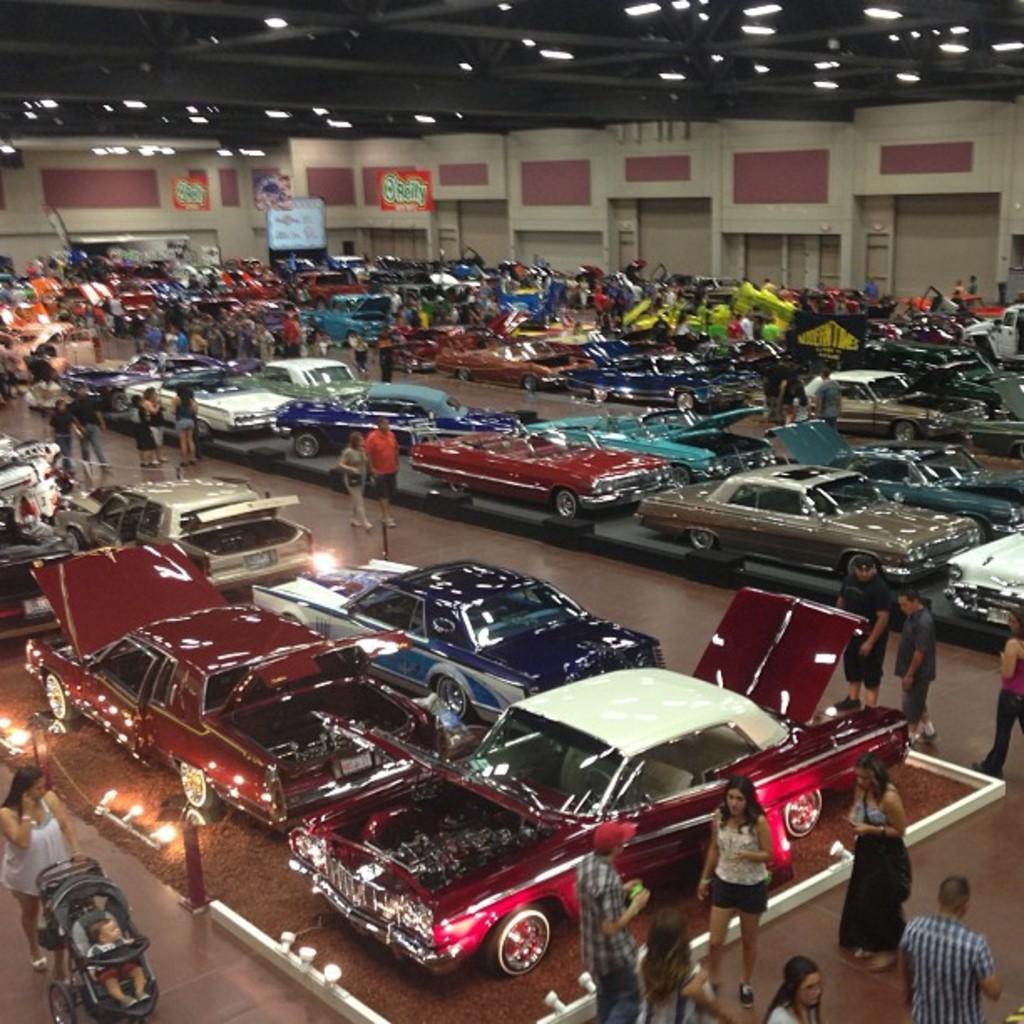Can you describe this image briefly? In this image I can see few cars and I can also see few persons, some are standing and some are walking. Background I can see few banners, lights and the wall is in cream and maroon color. 